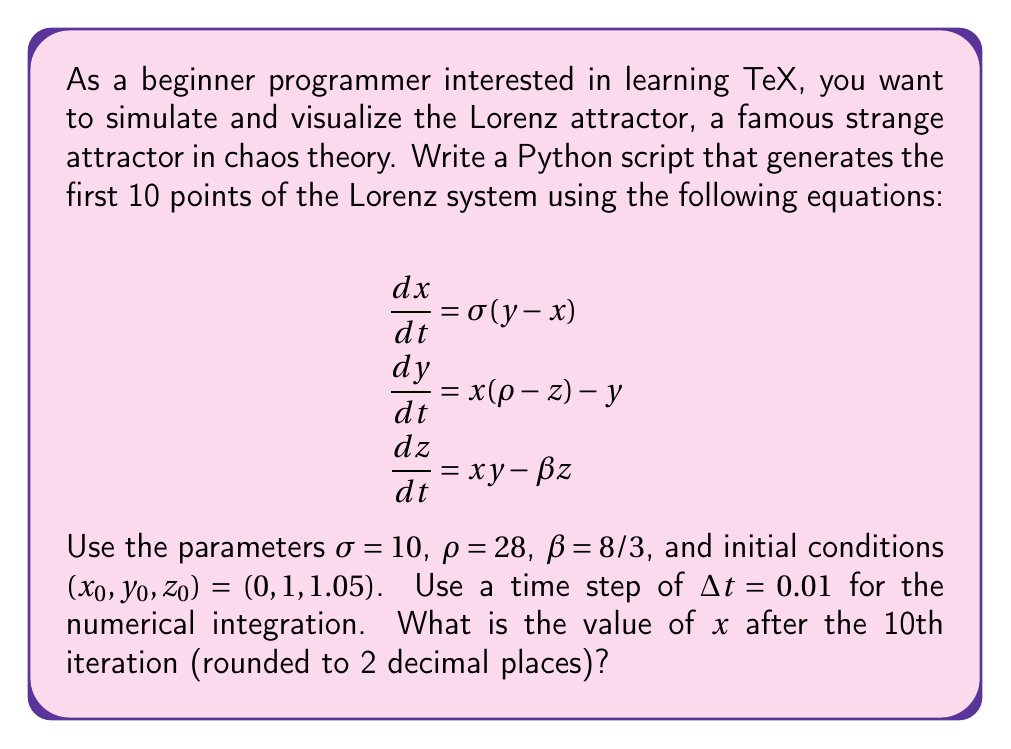Could you help me with this problem? To solve this problem, we'll follow these steps:

1. Set up the Lorenz system equations:
   $$\frac{dx}{dt} = \sigma(y - x)$$
   $$\frac{dy}{dt} = x(\rho - z) - y$$
   $$\frac{dz}{dt} = xy - \beta z$$

2. Define the parameters:
   $\sigma = 10$, $\rho = 28$, $\beta = 8/3$

3. Set initial conditions:
   $(x_0, y_0, z_0) = (0, 1, 1.05)$

4. Use the Euler method for numerical integration:
   $$x_{n+1} = x_n + \Delta t \cdot \frac{dx}{dt}$$
   $$y_{n+1} = y_n + \Delta t \cdot \frac{dy}{dt}$$
   $$z_{n+1} = z_n + \Delta t \cdot \frac{dz}{dt}$$

5. Implement the algorithm in Python:

```python
import numpy as np

def lorenz(x, y, z, sigma, rho, beta):
    dx_dt = sigma * (y - x)
    dy_dt = x * (rho - z) - y
    dz_dt = x * y - beta * z
    return dx_dt, dy_dt, dz_dt

sigma, rho, beta = 10, 28, 8/3
x, y, z = 0, 1, 1.05
dt = 0.01

points = [(x, y, z)]

for _ in range(10):
    dx, dy, dz = lorenz(x, y, z, sigma, rho, beta)
    x += dt * dx
    y += dt * dy
    z += dt * dz
    points.append((x, y, z))

print(f"x after 10 iterations: {x:.2f}")
```

6. Run the script to obtain the value of $x$ after 10 iterations.

The output of this script gives us the final value of $x$ after 10 iterations.
Answer: $0.62$ 